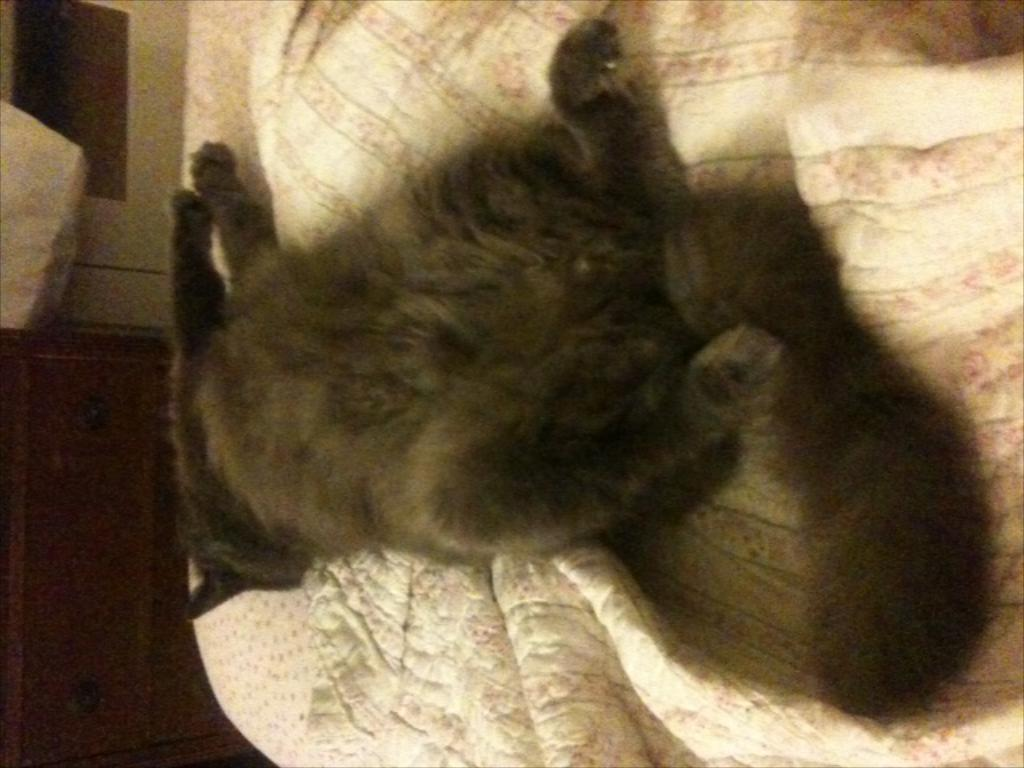What is the main subject of the image? There is an animal lying in the image. What is located at the bottom of the image? There is a bed sheet at the bottom of the image. What can be seen in the background of the image? There appears to be a cupboard in the background of the image. Where is the kettle placed in the image? There is no kettle present in the image. What type of ornament is hanging from the cupboard in the image? There is no ornament hanging from the cupboard in the image; only the cupboard is visible. 